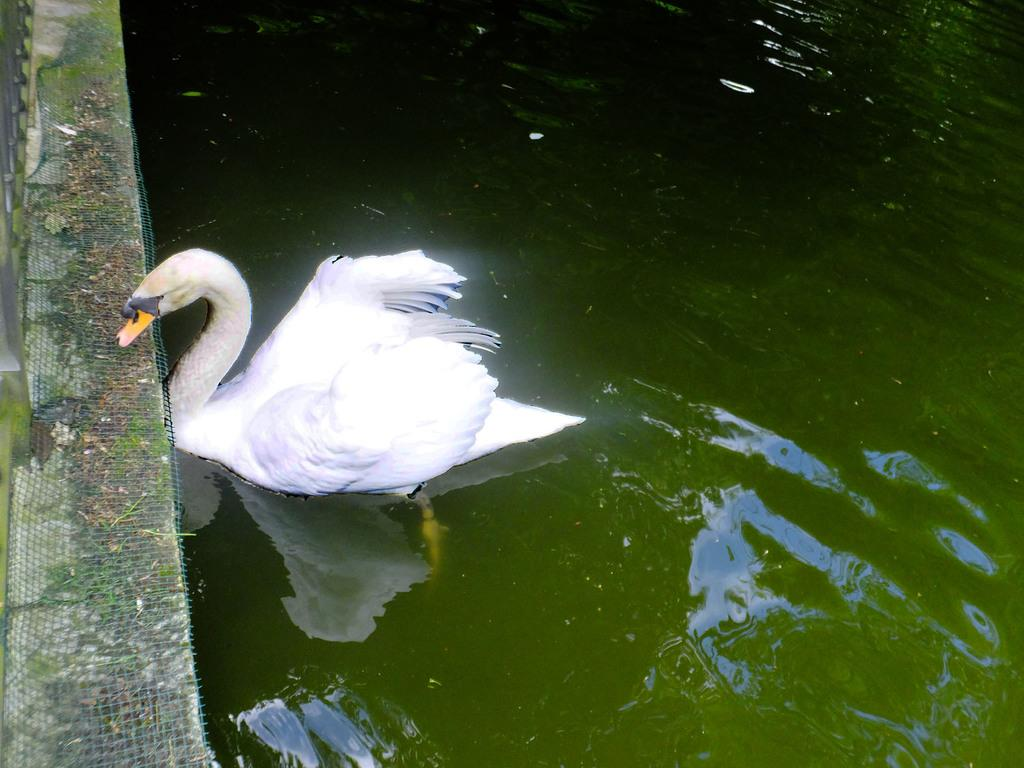What animal is present in the image? There is a duck in the image. Where is the duck located? The duck is in the water. Can you see a person sneezing in the image? There is no person present in the image, and therefore no sneezing can be observed. What type of rat can be seen swimming with the duck in the image? There is no rat present in the image; it only features a duck in the water. 